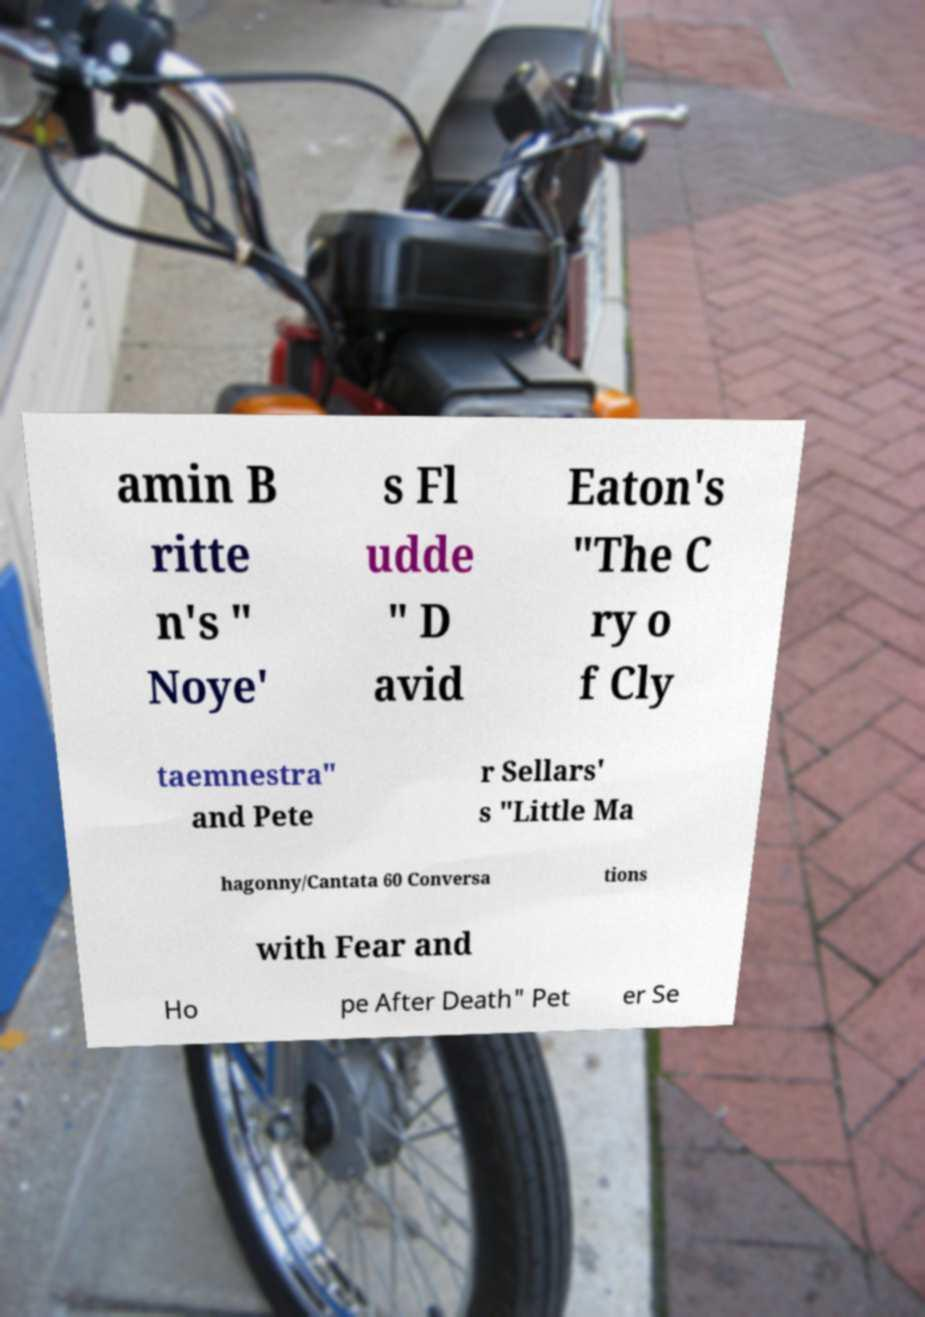What messages or text are displayed in this image? I need them in a readable, typed format. amin B ritte n's " Noye' s Fl udde " D avid Eaton's "The C ry o f Cly taemnestra" and Pete r Sellars' s "Little Ma hagonny/Cantata 60 Conversa tions with Fear and Ho pe After Death" Pet er Se 